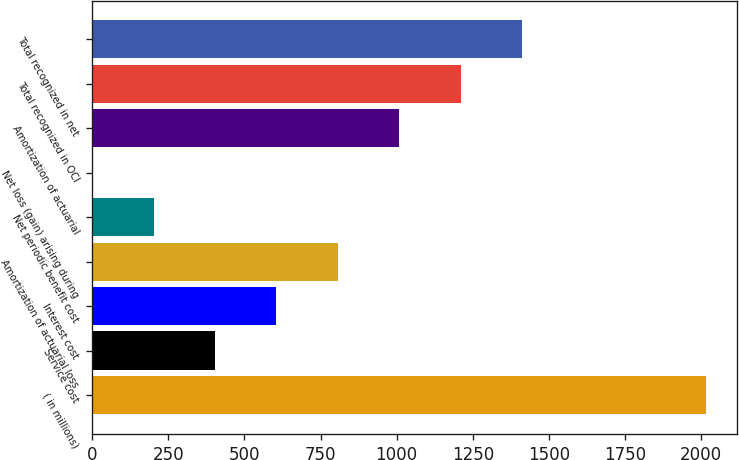Convert chart. <chart><loc_0><loc_0><loc_500><loc_500><bar_chart><fcel>( in millions)<fcel>Service cost<fcel>Interest cost<fcel>Amortization of actuarial loss<fcel>Net periodic benefit cost<fcel>Net loss (gain) arising during<fcel>Amortization of actuarial<fcel>Total recognized in OCI<fcel>Total recognized in net<nl><fcel>2016<fcel>403.28<fcel>604.87<fcel>806.46<fcel>201.69<fcel>0.1<fcel>1008.05<fcel>1209.64<fcel>1411.23<nl></chart> 